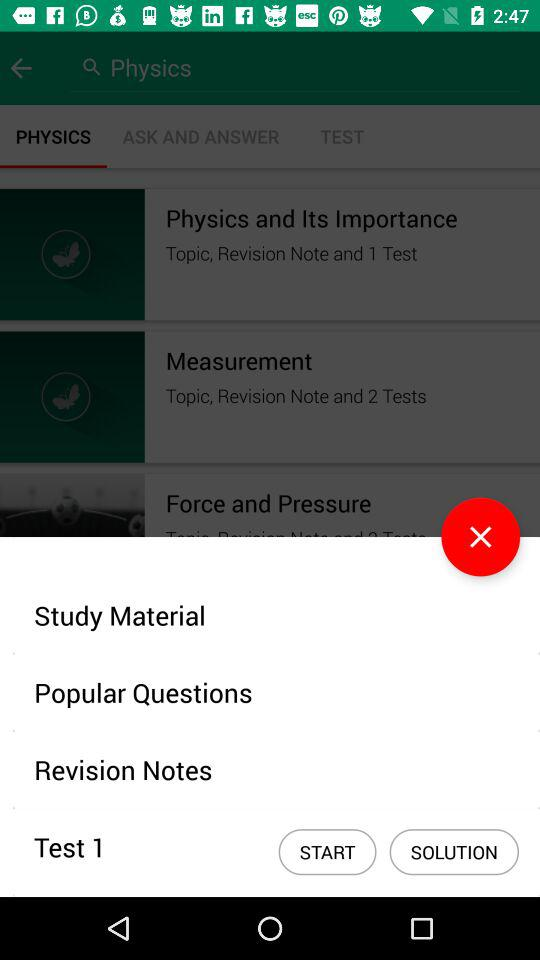How many tests are there in total?
Answer the question using a single word or phrase. 3 